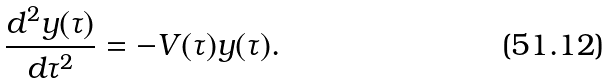<formula> <loc_0><loc_0><loc_500><loc_500>\frac { d ^ { 2 } y ( \tau ) } { d \tau ^ { 2 } } = - V ( \tau ) y ( \tau ) .</formula> 